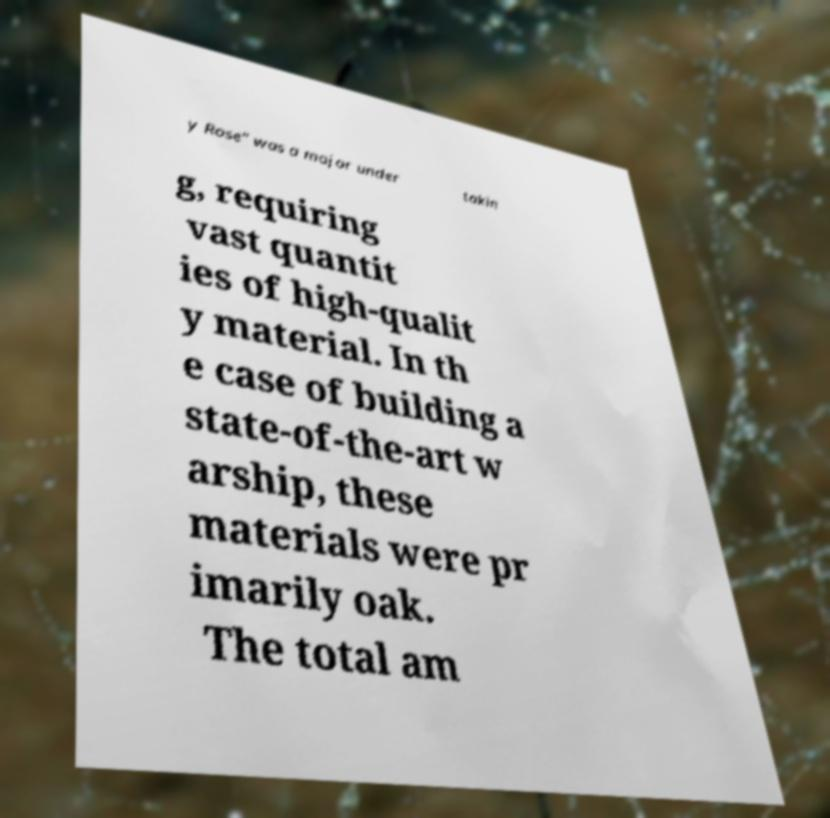What messages or text are displayed in this image? I need them in a readable, typed format. y Rose" was a major under takin g, requiring vast quantit ies of high-qualit y material. In th e case of building a state-of-the-art w arship, these materials were pr imarily oak. The total am 